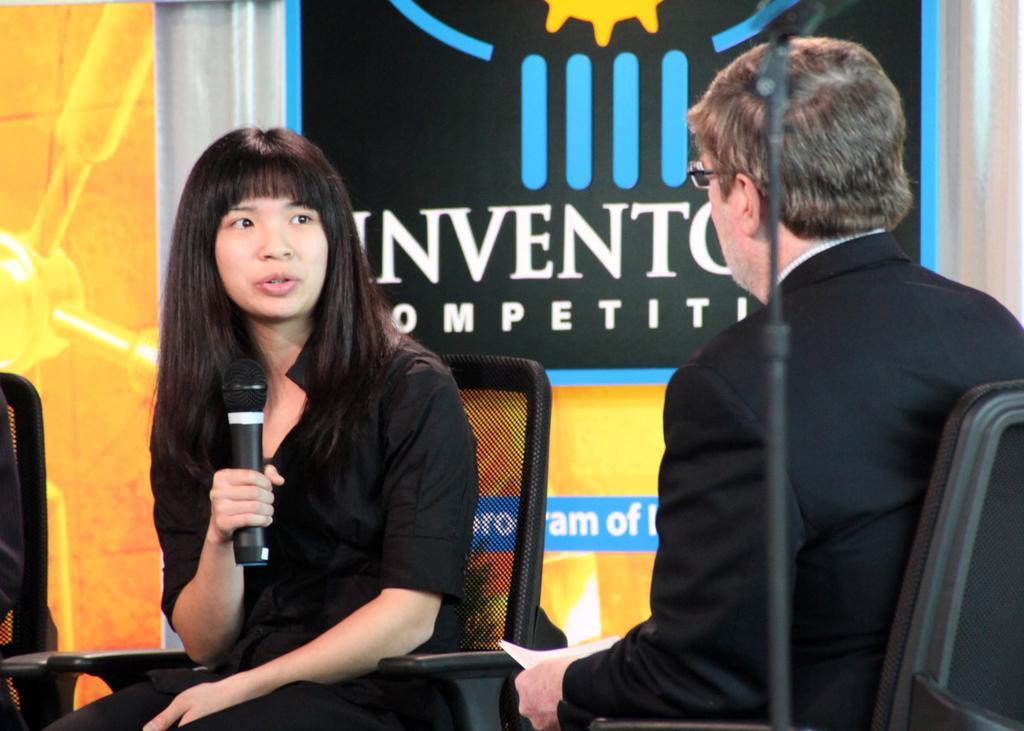In one or two sentences, can you explain what this image depicts? In this picture we can see a man wore a spectacle and sitting on a chair and holding a paper with his hand and in front of him we can see a woman holding a mic with her hand and sitting on a chair and in the background we can see banners. 